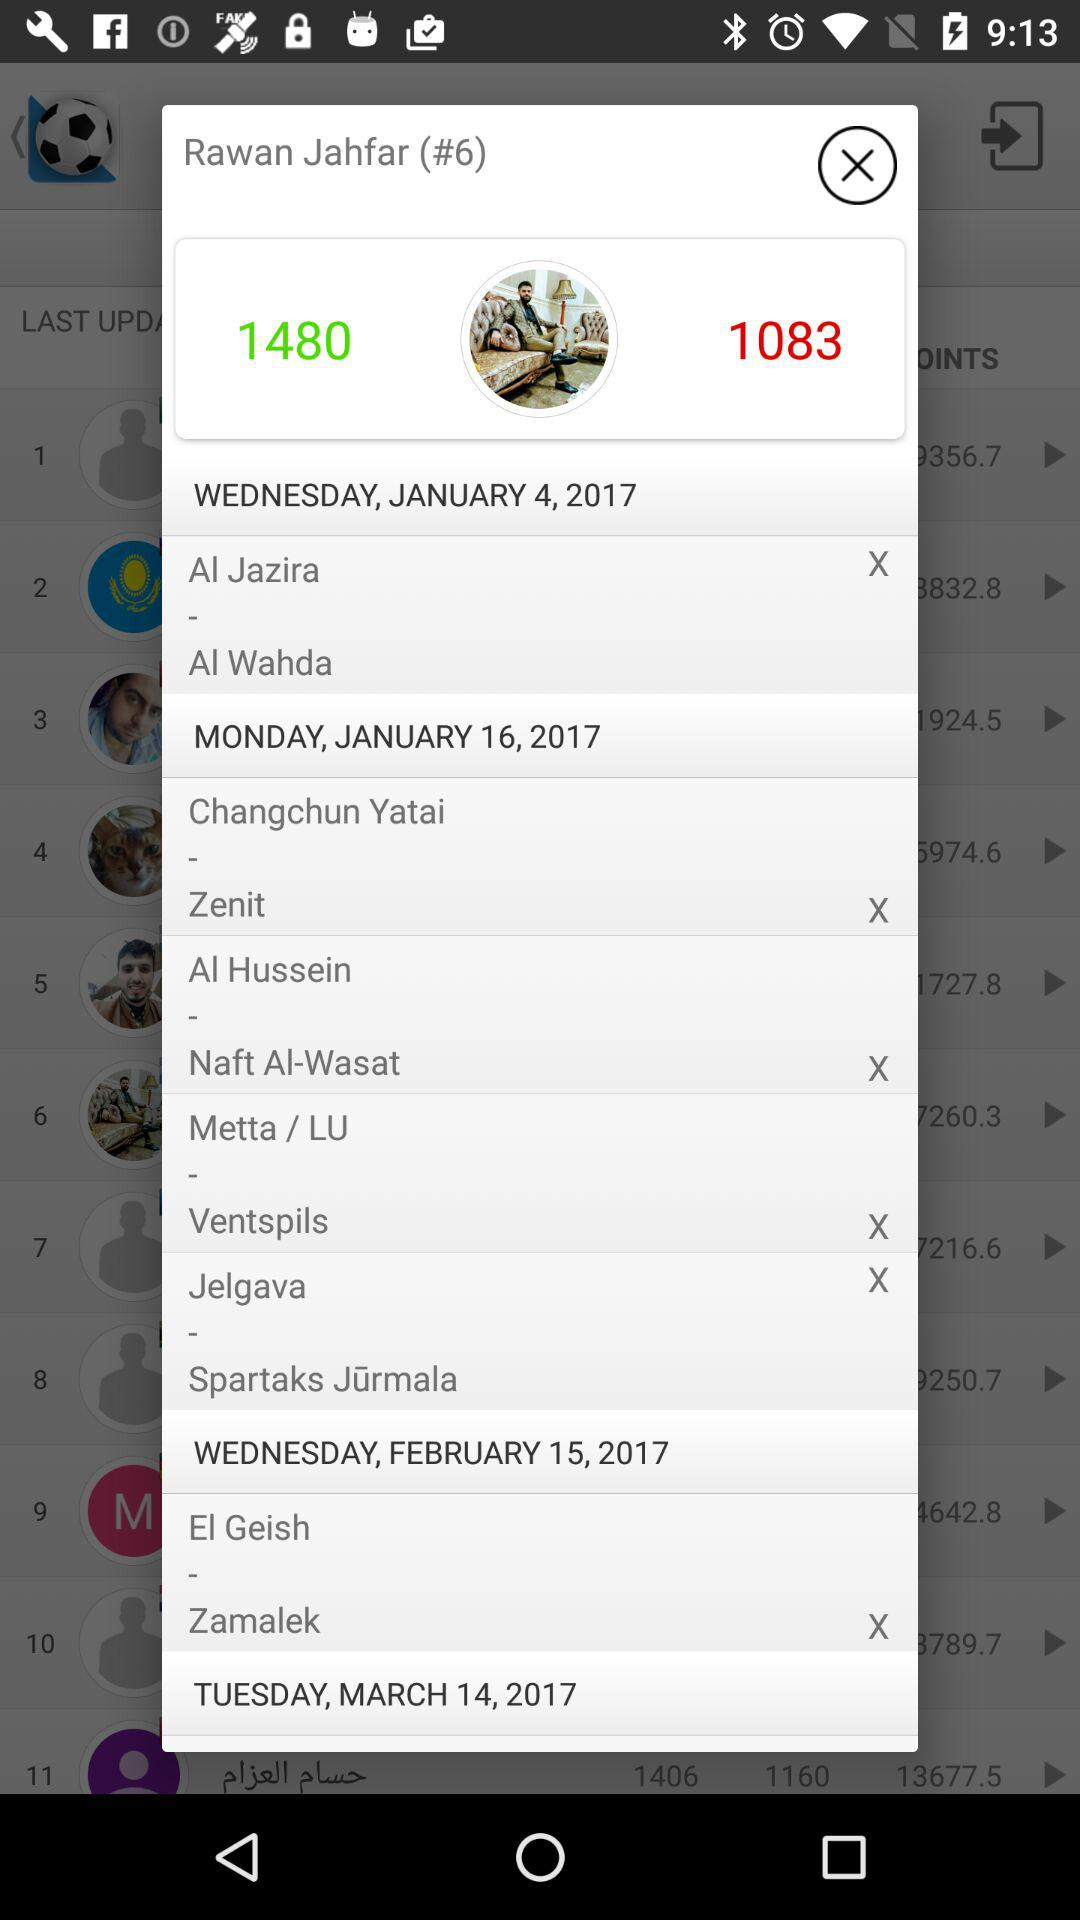What is the name of the user? The name of the user is Rawan Jahfar. 